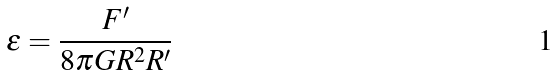<formula> <loc_0><loc_0><loc_500><loc_500>\epsilon = \frac { F ^ { \prime } } { 8 \pi G R ^ { 2 } R ^ { \prime } }</formula> 